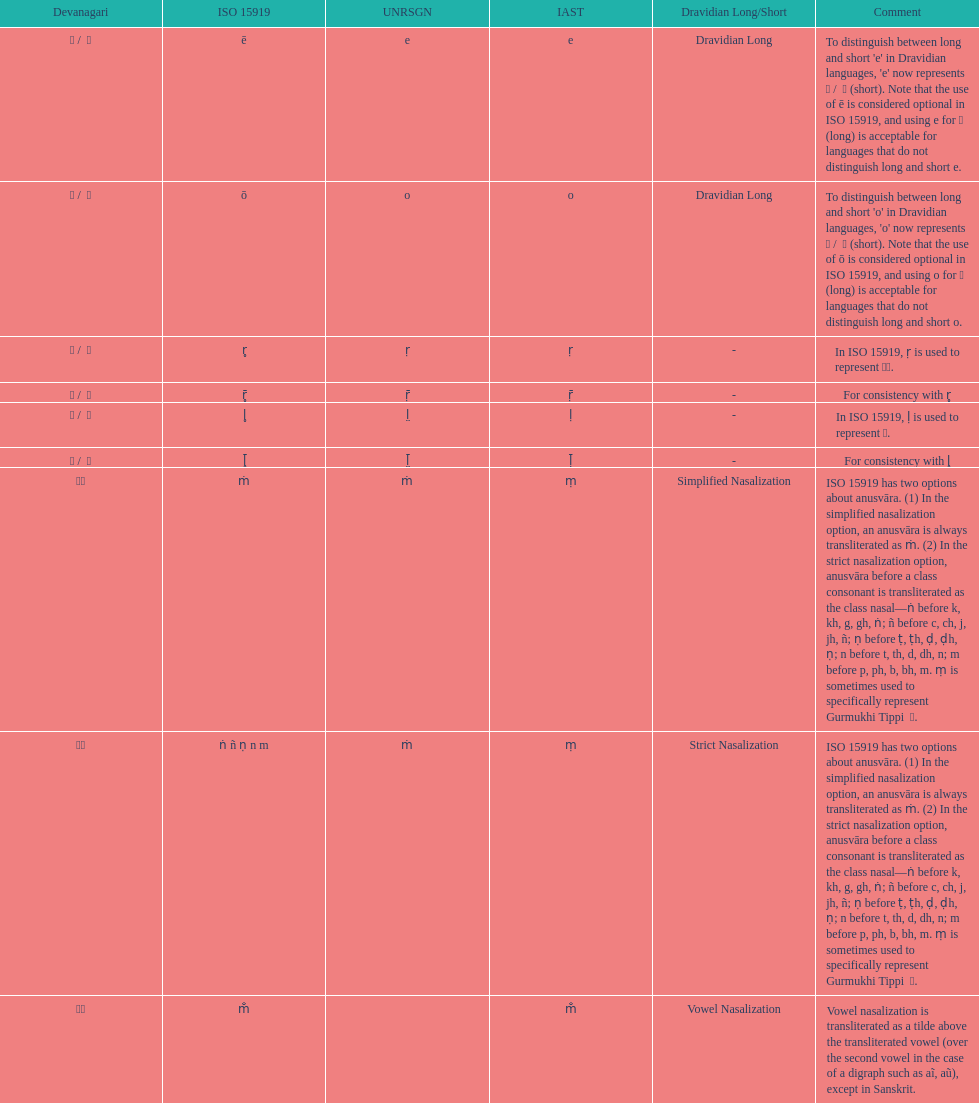Which devanagari transliteration is listed on the top of the table? ए / े. 